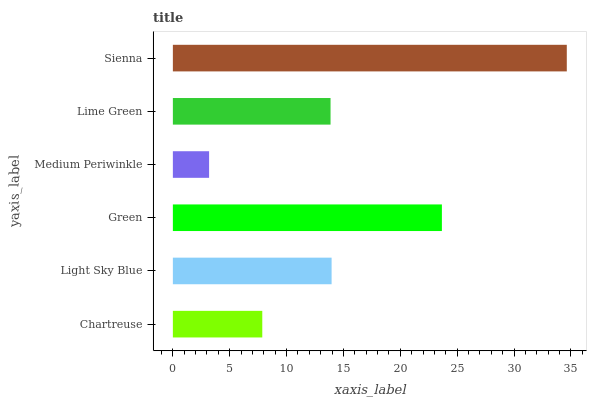Is Medium Periwinkle the minimum?
Answer yes or no. Yes. Is Sienna the maximum?
Answer yes or no. Yes. Is Light Sky Blue the minimum?
Answer yes or no. No. Is Light Sky Blue the maximum?
Answer yes or no. No. Is Light Sky Blue greater than Chartreuse?
Answer yes or no. Yes. Is Chartreuse less than Light Sky Blue?
Answer yes or no. Yes. Is Chartreuse greater than Light Sky Blue?
Answer yes or no. No. Is Light Sky Blue less than Chartreuse?
Answer yes or no. No. Is Light Sky Blue the high median?
Answer yes or no. Yes. Is Lime Green the low median?
Answer yes or no. Yes. Is Sienna the high median?
Answer yes or no. No. Is Green the low median?
Answer yes or no. No. 